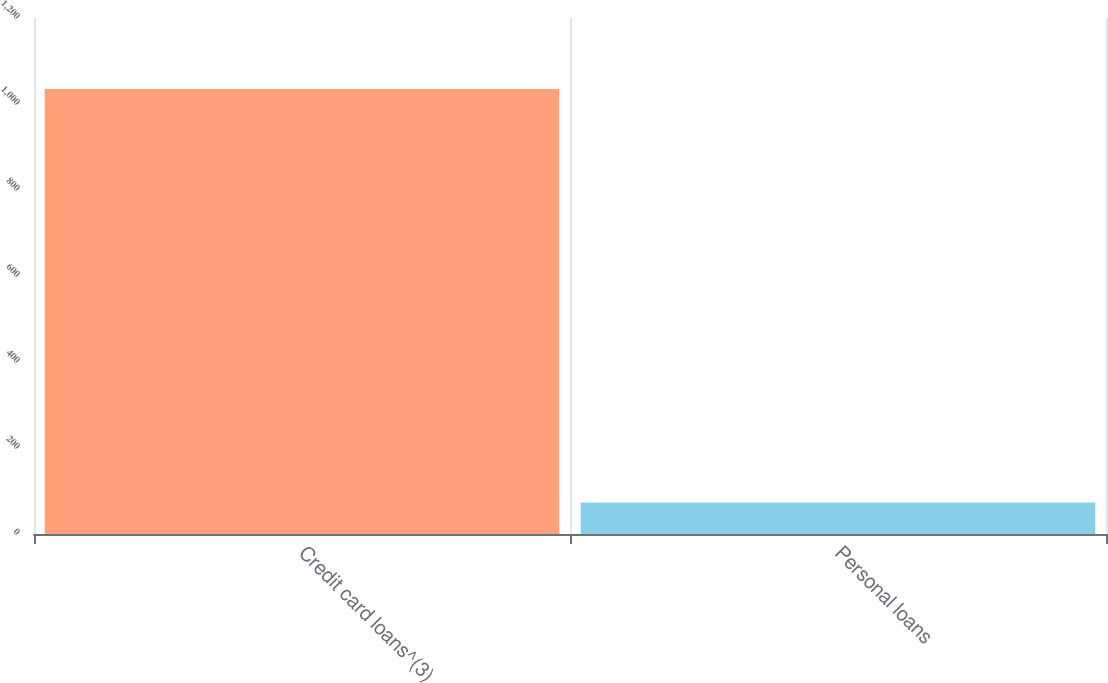<chart> <loc_0><loc_0><loc_500><loc_500><bar_chart><fcel>Credit card loans^(3)<fcel>Personal loans<nl><fcel>1035<fcel>73<nl></chart> 